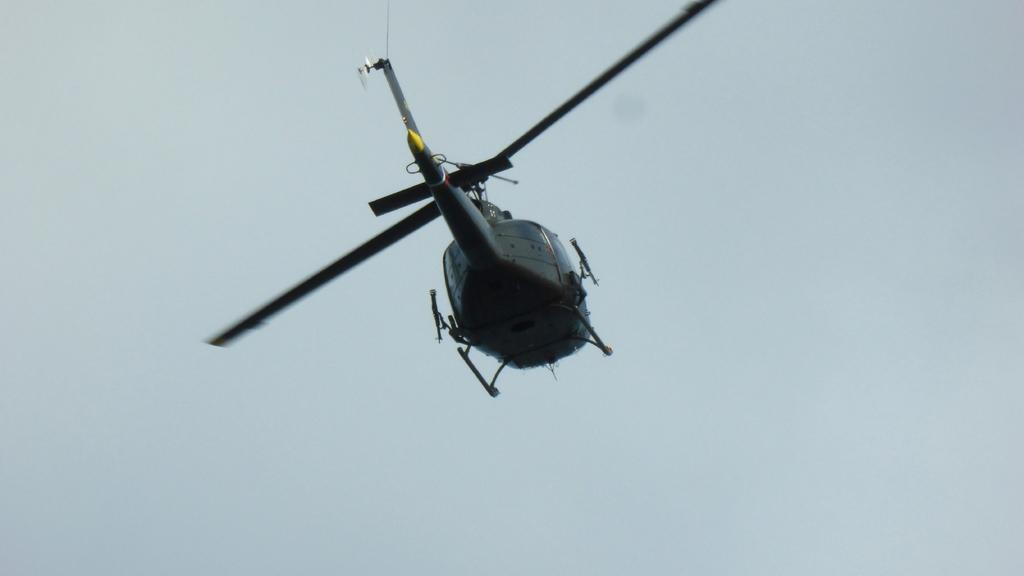What type of aircraft is in the picture? There is a black helicopter in the picture. What is the helicopter doing in the image? The helicopter is flying. How would you describe the sky in the image? The sky is blue and clear in the image. How many wishes can be granted by the helicopter in the image? There are no wishes associated with the helicopter in the image; it is simply a flying aircraft. 